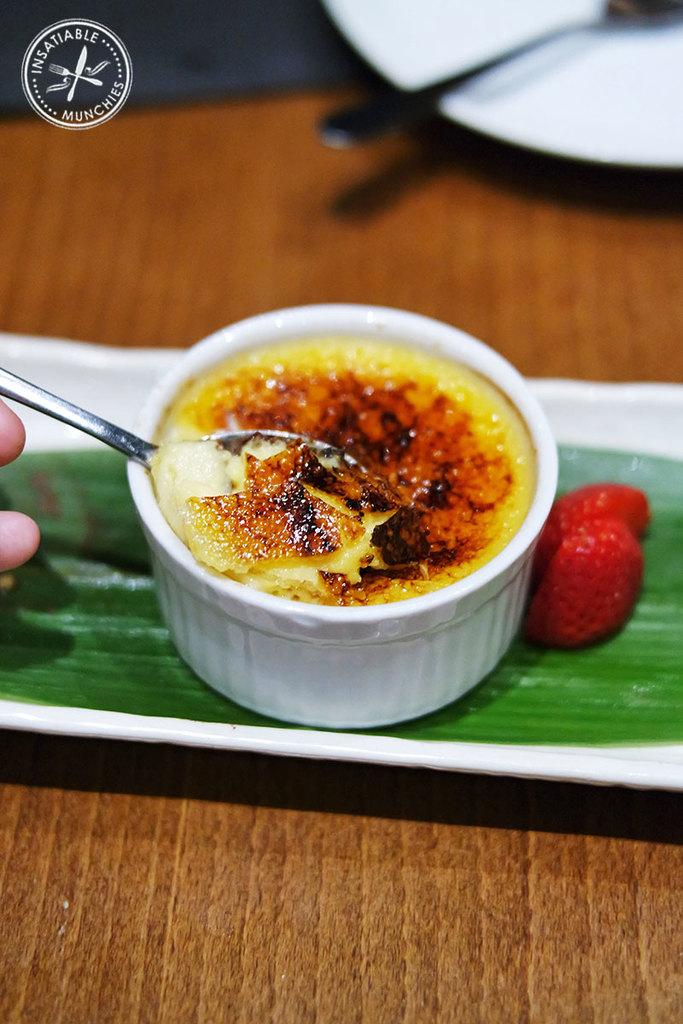What object is present in the image that can hold multiple items? There is a tray in the image that can hold multiple items. Where is the plate located in the image? The plate is on a wooden platform in the image. What type of container is present in the image? There is a bowl in the image. What utensils are visible in the image? Spoons are visible in the image. What type of food can be seen in the image? There is food in the image. What natural element is present in the image? A leaf is present in the image. Whose fingers are visible in the image? A person's fingers are visible in the image. What is located in the top left corner of the image? There is a logo in the top left corner of the image. What type of plough can be seen in the image? There is no plough present in the image. How does the earthquake affect the wooden platform in the image? There is no earthquake present in the image, so its effects cannot be observed. 